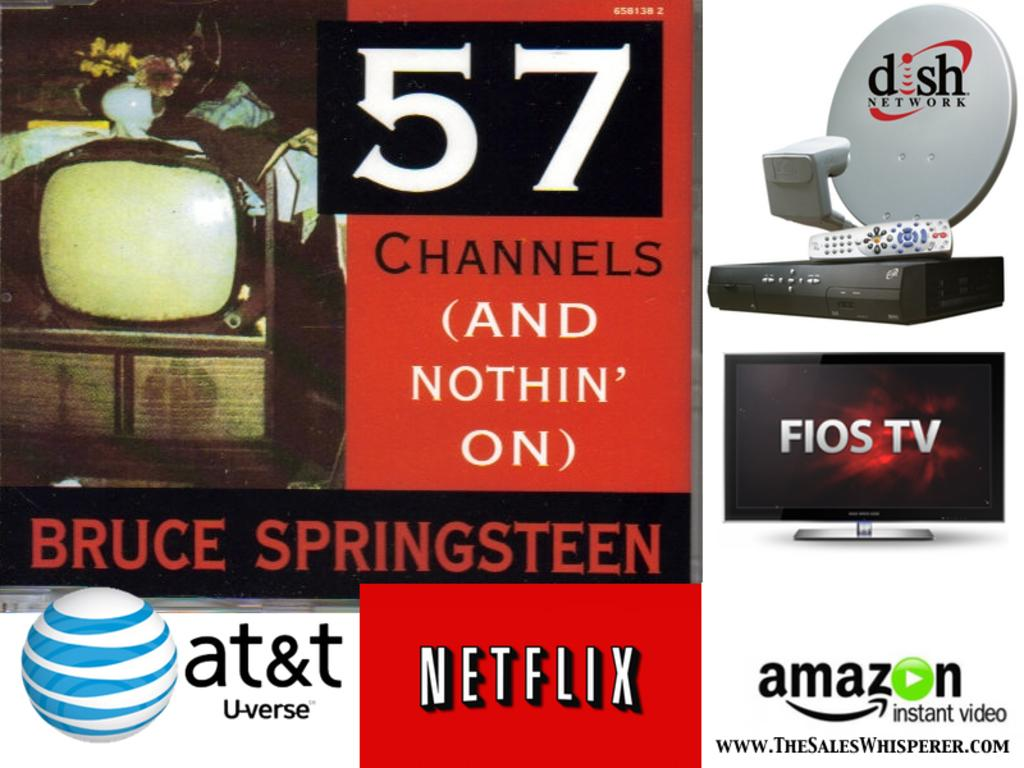Provide a one-sentence caption for the provided image. Several different television providers such as at&t, Netflix, and Amazon are displayed on an advertisement. 